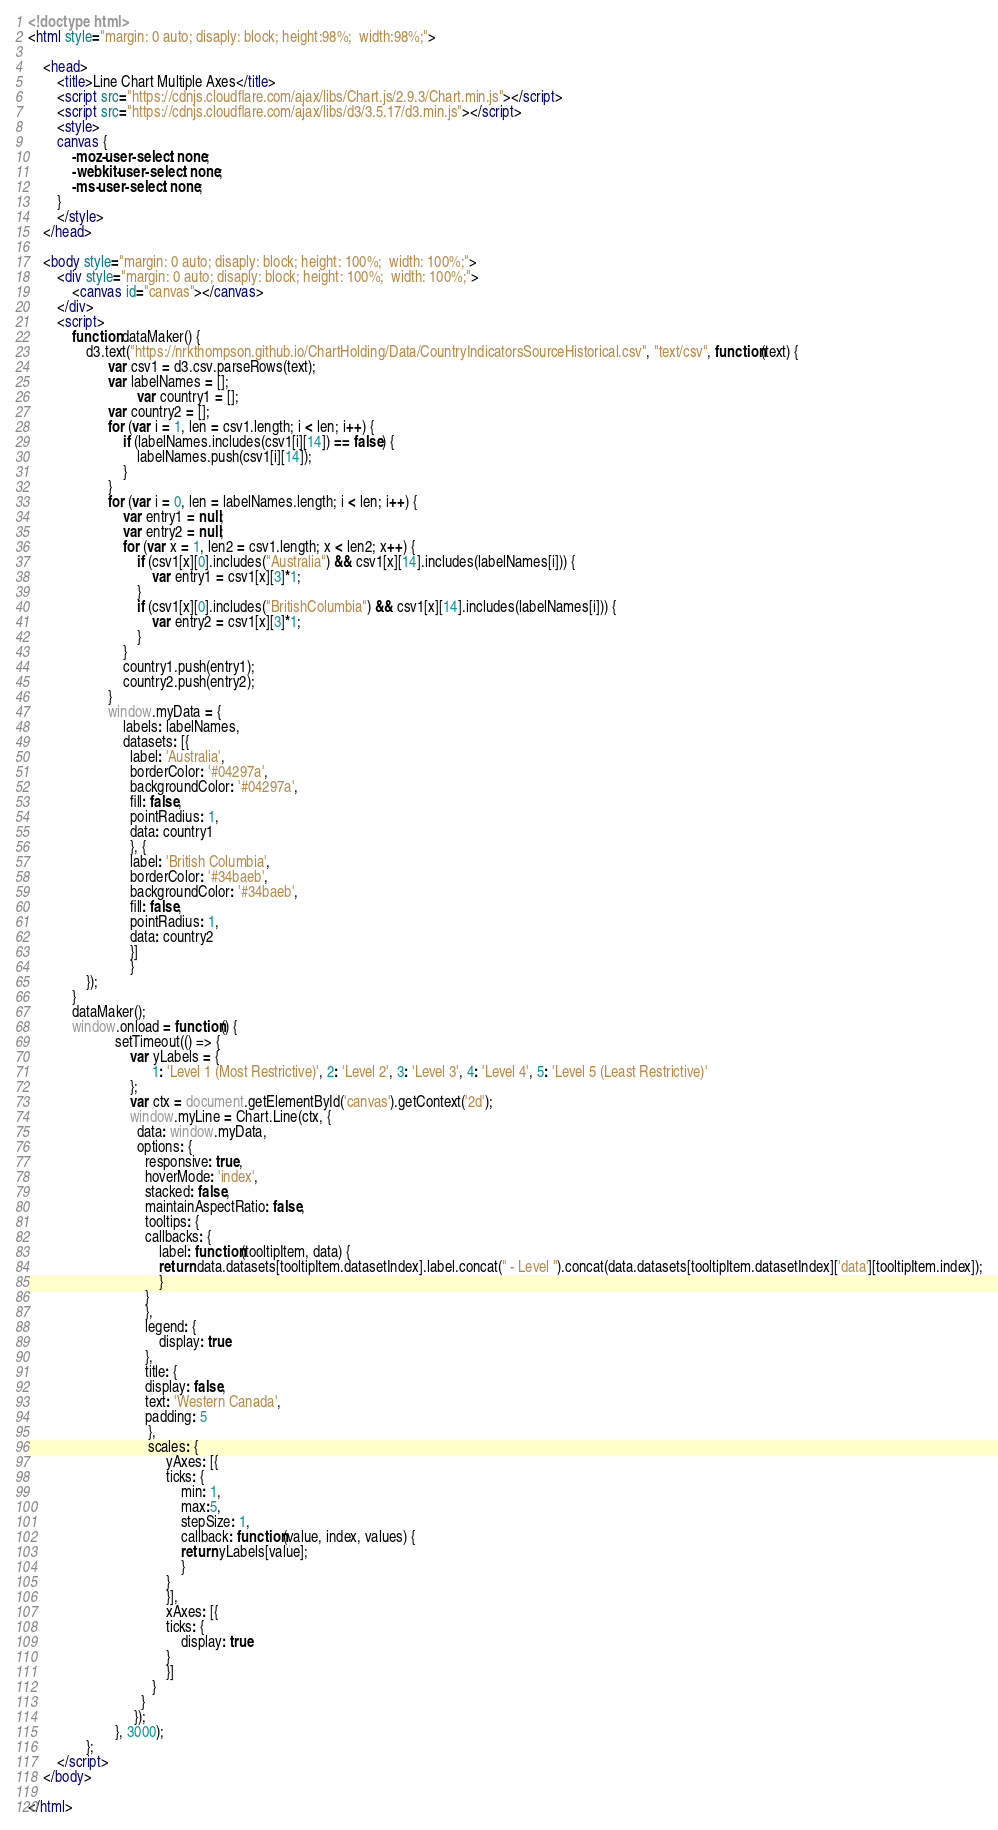Convert code to text. <code><loc_0><loc_0><loc_500><loc_500><_HTML_>
<!doctype html>
<html style="margin: 0 auto; disaply: block; height:98%;  width:98%;">

	<head>
		<title>Line Chart Multiple Axes</title>
		<script src="https://cdnjs.cloudflare.com/ajax/libs/Chart.js/2.9.3/Chart.min.js"></script>
		<script src="https://cdnjs.cloudflare.com/ajax/libs/d3/3.5.17/d3.min.js"></script>
		<style>
		canvas {
			-moz-user-select: none;
			-webkit-user-select: none;
			-ms-user-select: none;
		}
		</style>
	</head>

	<body style="margin: 0 auto; disaply: block; height: 100%;  width: 100%;">
		<div style="margin: 0 auto; disaply: block; height: 100%;  width: 100%;">
			<canvas id="canvas"></canvas>
		</div>
		<script>
			function dataMaker() {
				d3.text("https://nrkthompson.github.io/ChartHolding/Data/CountryIndicatorsSourceHistorical.csv", "text/csv", function(text) {
					  var csv1 = d3.csv.parseRows(text);
					  var labelNames = [];
            				  var country1 = [];
					  var country2 = [];
					  for (var i = 1, len = csv1.length; i < len; i++) {
						  if (labelNames.includes(csv1[i][14]) == false) {
							  labelNames.push(csv1[i][14]);
						  }
					  }
					  for (var i = 0, len = labelNames.length; i < len; i++) {
						  var entry1 = null;
						  var entry2 = null;
						  for (var x = 1, len2 = csv1.length; x < len2; x++) {
							  if (csv1[x][0].includes("Australia") && csv1[x][14].includes(labelNames[i])) {
								  var entry1 = csv1[x][3]*1;
							  }
							  if (csv1[x][0].includes("BritishColumbia") && csv1[x][14].includes(labelNames[i])) {
								  var entry2 = csv1[x][3]*1;
							  }
						  }
						  country1.push(entry1);
						  country2.push(entry2);
					  }
					  window.myData = {
						  labels: labelNames,
						  datasets: [{
						    label: 'Australia',
						    borderColor: '#04297a',
						    backgroundColor: '#04297a',
						    fill: false,
						    pointRadius: 1,
						    data: country1
						    }, {
						    label: 'British Columbia',
						    borderColor: '#34baeb',
						    backgroundColor: '#34baeb',
						    fill: false,
						    pointRadius: 1,
						    data: country2
						    }]
						    }  
				});
			}
			dataMaker();
			window.onload = function() {
						setTimeout(() => { 
							var yLabels = {
							      1: 'Level 1 (Most Restrictive)', 2: 'Level 2', 3: 'Level 3', 4: 'Level 4', 5: 'Level 5 (Least Restrictive)'
							};
							var ctx = document.getElementById('canvas').getContext('2d');
							window.myLine = Chart.Line(ctx, {
							  data: window.myData,
							  options: {
							    responsive: true,
							    hoverMode: 'index',
							    stacked: false,
							    maintainAspectRatio: false,
							    tooltips: {
								callbacks: {
								    label: function(tooltipItem, data) {
									return data.datasets[tooltipItem.datasetIndex].label.concat(" - Level ").concat(data.datasets[tooltipItem.datasetIndex]['data'][tooltipItem.index]);
								    }
								}
							    },
							    legend: {
								    display: true
							    },
							    title: {
								display: false,
								text: 'Western Canada',
								padding: 5
							     },
							     scales: {
								      yAxes: [{
									  ticks: {
									      min: 1,
									      max:5,
									      stepSize: 1,
									      callback: function(value, index, values) {
										  return yLabels[value];
									      }
									  }
								      }],
								      xAxes: [{
									  ticks: {
									      display: true
									  }
								      }]
								  }
							   }
							 });
						}, 3000);
				};
		</script>
	</body>

</html></code> 